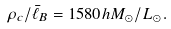<formula> <loc_0><loc_0><loc_500><loc_500>\rho _ { c } / { \bar { \ell } _ { B } } = 1 5 8 0 h M _ { \odot } / L _ { \odot } .</formula> 